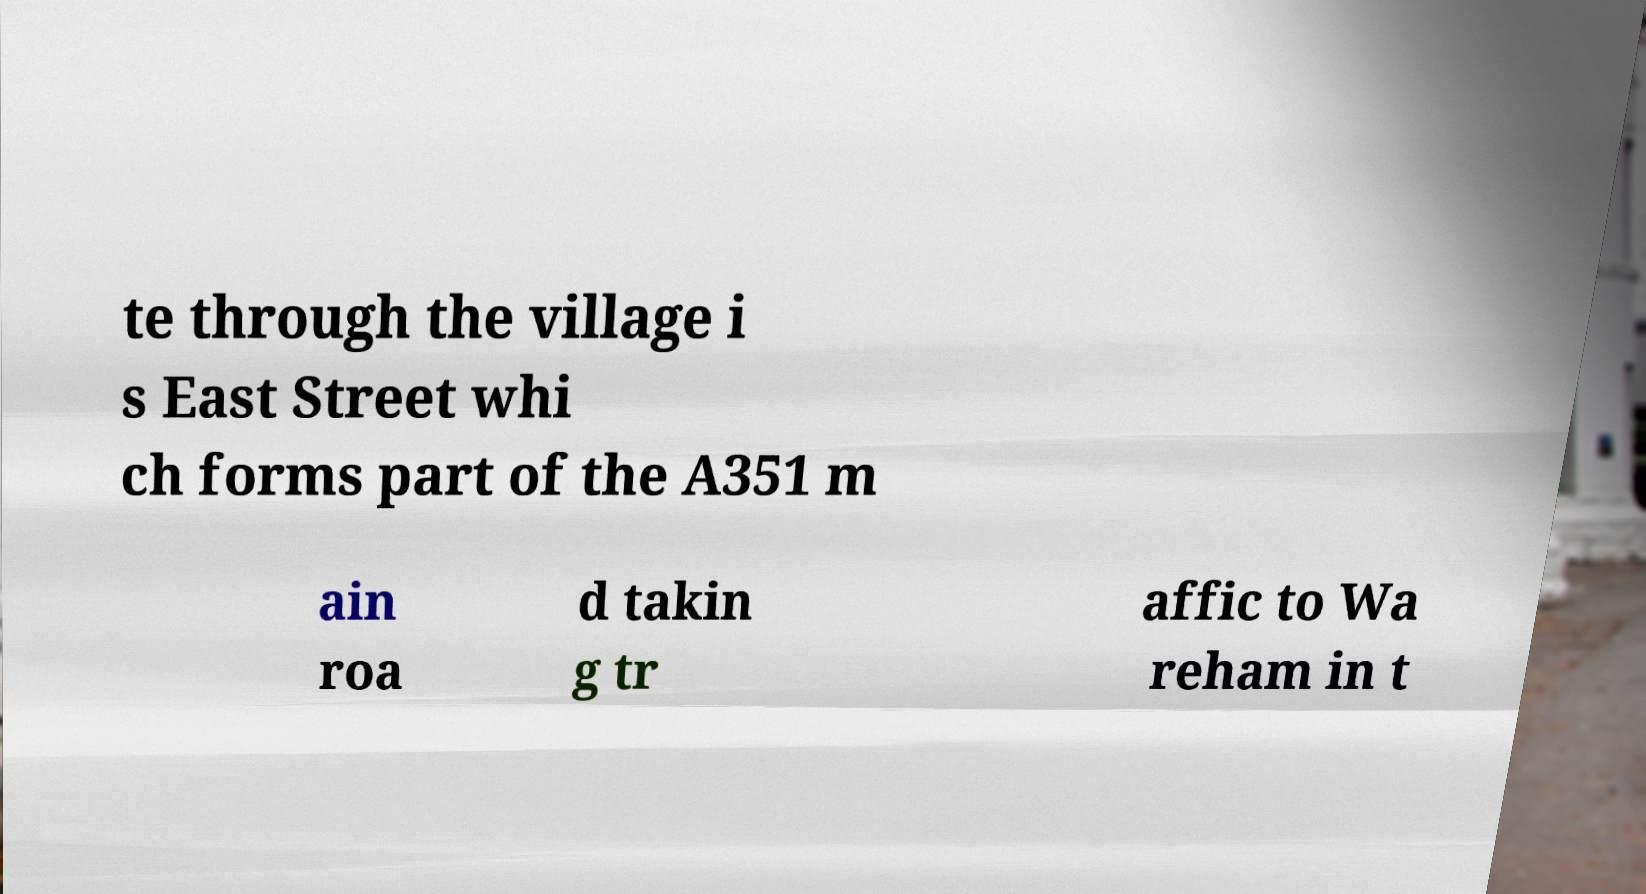Can you read and provide the text displayed in the image?This photo seems to have some interesting text. Can you extract and type it out for me? te through the village i s East Street whi ch forms part of the A351 m ain roa d takin g tr affic to Wa reham in t 